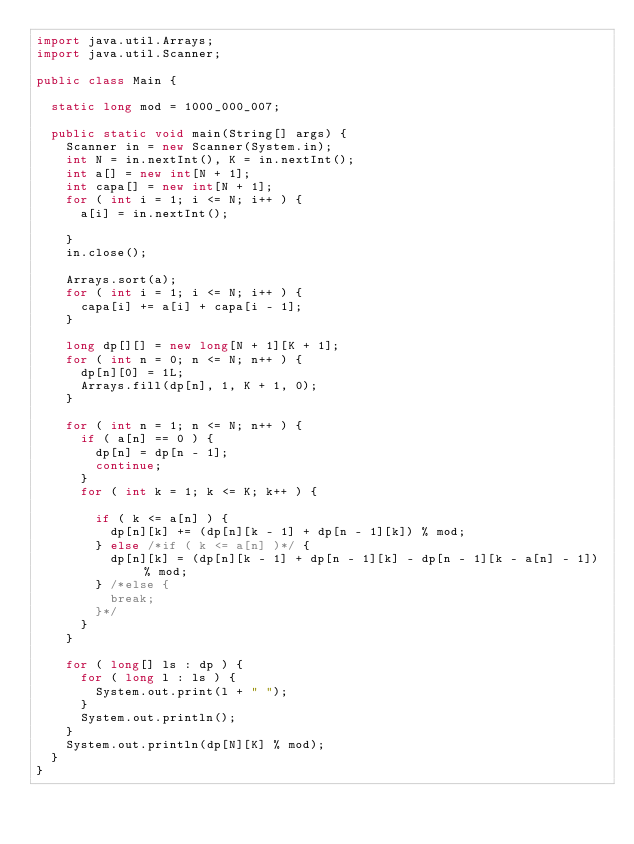<code> <loc_0><loc_0><loc_500><loc_500><_Java_>import java.util.Arrays;
import java.util.Scanner;

public class Main {

	static long mod = 1000_000_007;

	public static void main(String[] args) {
		Scanner in = new Scanner(System.in);
		int N = in.nextInt(), K = in.nextInt();
		int a[] = new int[N + 1];
		int capa[] = new int[N + 1];
		for ( int i = 1; i <= N; i++ ) {
			a[i] = in.nextInt();

		}
		in.close();

		Arrays.sort(a);
		for ( int i = 1; i <= N; i++ ) {
			capa[i] += a[i] + capa[i - 1];
		}

		long dp[][] = new long[N + 1][K + 1];
		for ( int n = 0; n <= N; n++ ) {
			dp[n][0] = 1L;
			Arrays.fill(dp[n], 1, K + 1, 0);
		}

		for ( int n = 1; n <= N; n++ ) {
			if ( a[n] == 0 ) {
				dp[n] = dp[n - 1];
				continue;
			}
			for ( int k = 1; k <= K; k++ ) {

				if ( k <= a[n] ) {
					dp[n][k] += (dp[n][k - 1] + dp[n - 1][k]) % mod;
				} else /*if ( k <= a[n] )*/ {
					dp[n][k] = (dp[n][k - 1] + dp[n - 1][k] - dp[n - 1][k - a[n] - 1]) % mod;
				} /*else {
					break;
				}*/
			}
		}

		for ( long[] ls : dp ) {
			for ( long l : ls ) {
				System.out.print(l + " ");
			}
			System.out.println();
		}
		System.out.println(dp[N][K] % mod);
	}
}</code> 